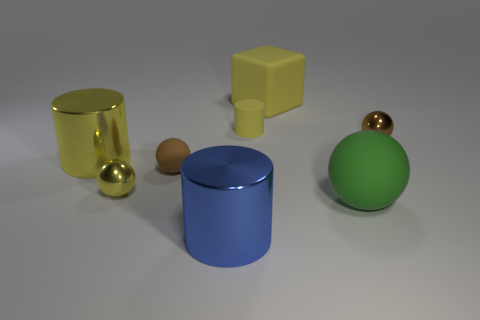Subtract all metallic cylinders. How many cylinders are left? 1 Add 1 tiny yellow metal things. How many objects exist? 9 Subtract all yellow spheres. How many spheres are left? 3 Subtract 1 blocks. How many blocks are left? 0 Add 4 brown metallic spheres. How many brown metallic spheres are left? 5 Add 8 blue cylinders. How many blue cylinders exist? 9 Subtract 0 brown cubes. How many objects are left? 8 Subtract all cylinders. How many objects are left? 5 Subtract all yellow spheres. Subtract all purple cubes. How many spheres are left? 3 Subtract all purple balls. How many yellow cylinders are left? 2 